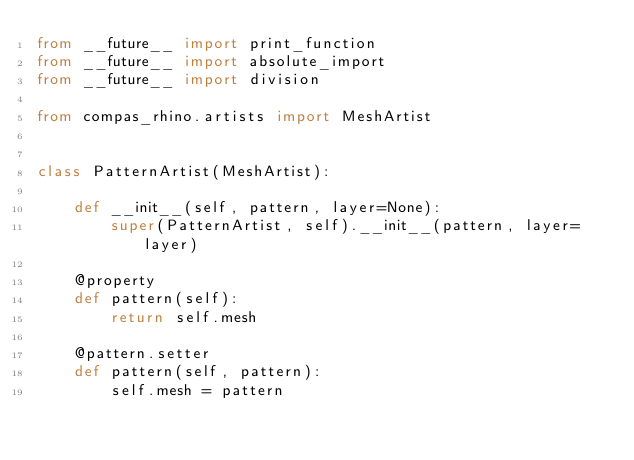<code> <loc_0><loc_0><loc_500><loc_500><_Python_>from __future__ import print_function
from __future__ import absolute_import
from __future__ import division

from compas_rhino.artists import MeshArtist


class PatternArtist(MeshArtist):

    def __init__(self, pattern, layer=None):
        super(PatternArtist, self).__init__(pattern, layer=layer)

    @property
    def pattern(self):
        return self.mesh

    @pattern.setter
    def pattern(self, pattern):
        self.mesh = pattern
</code> 